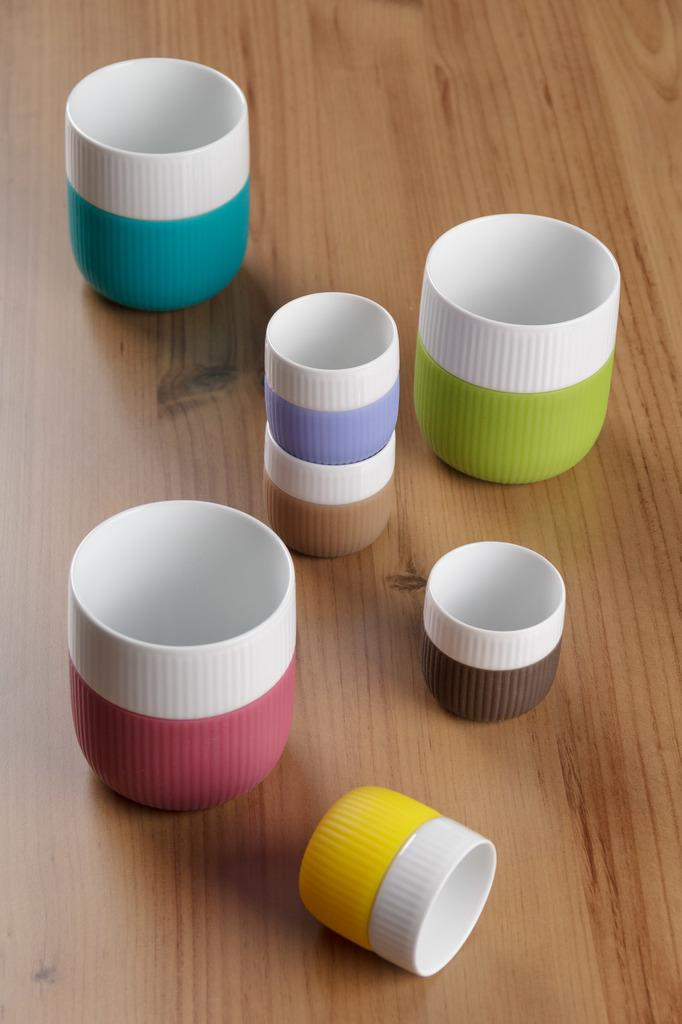What type of objects are present in the image? There are plastic things in the image. Where are the plastic objects placed? The plastic things are on a wooden board. What type of bushes can be seen growing on the ground in the image? There are no bushes or ground visible in the image; it only features plastic objects on a wooden board. 